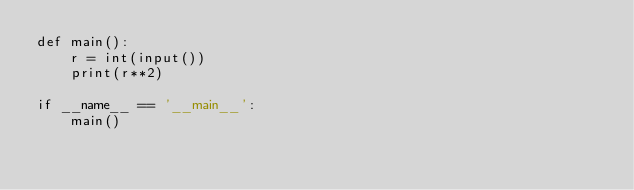Convert code to text. <code><loc_0><loc_0><loc_500><loc_500><_Python_>def main():
    r = int(input())
    print(r**2)

if __name__ == '__main__':
    main()</code> 